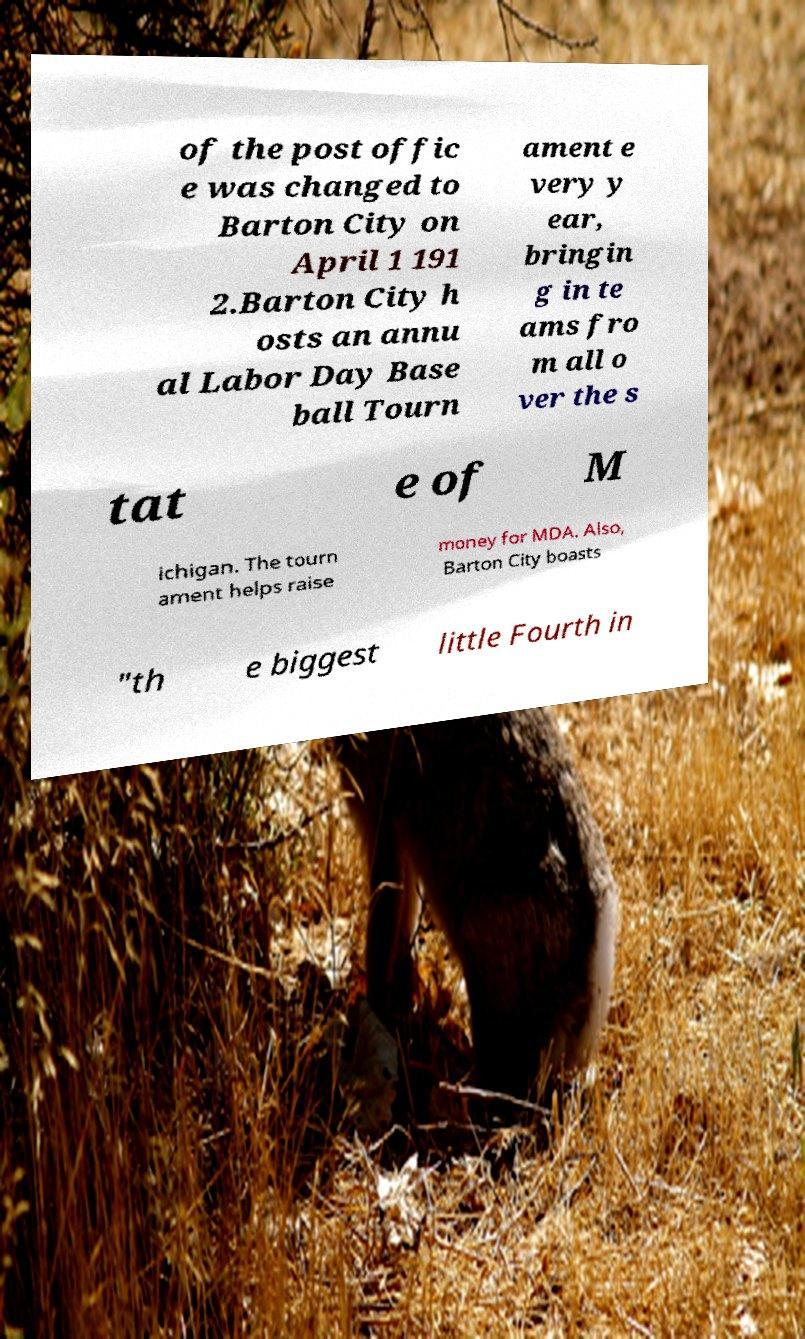I need the written content from this picture converted into text. Can you do that? of the post offic e was changed to Barton City on April 1 191 2.Barton City h osts an annu al Labor Day Base ball Tourn ament e very y ear, bringin g in te ams fro m all o ver the s tat e of M ichigan. The tourn ament helps raise money for MDA. Also, Barton City boasts "th e biggest little Fourth in 